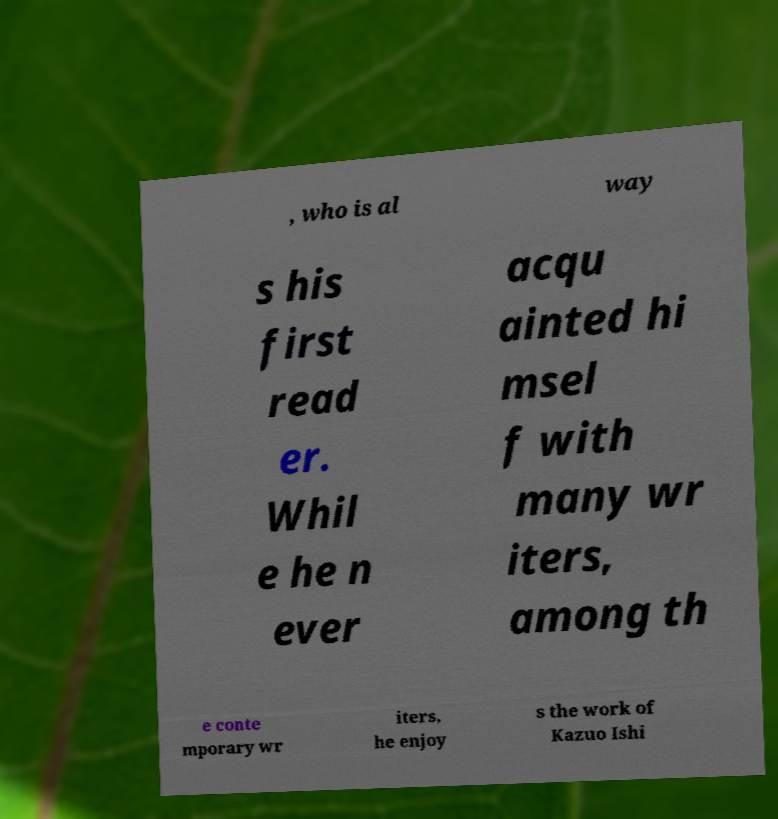What messages or text are displayed in this image? I need them in a readable, typed format. , who is al way s his first read er. Whil e he n ever acqu ainted hi msel f with many wr iters, among th e conte mporary wr iters, he enjoy s the work of Kazuo Ishi 